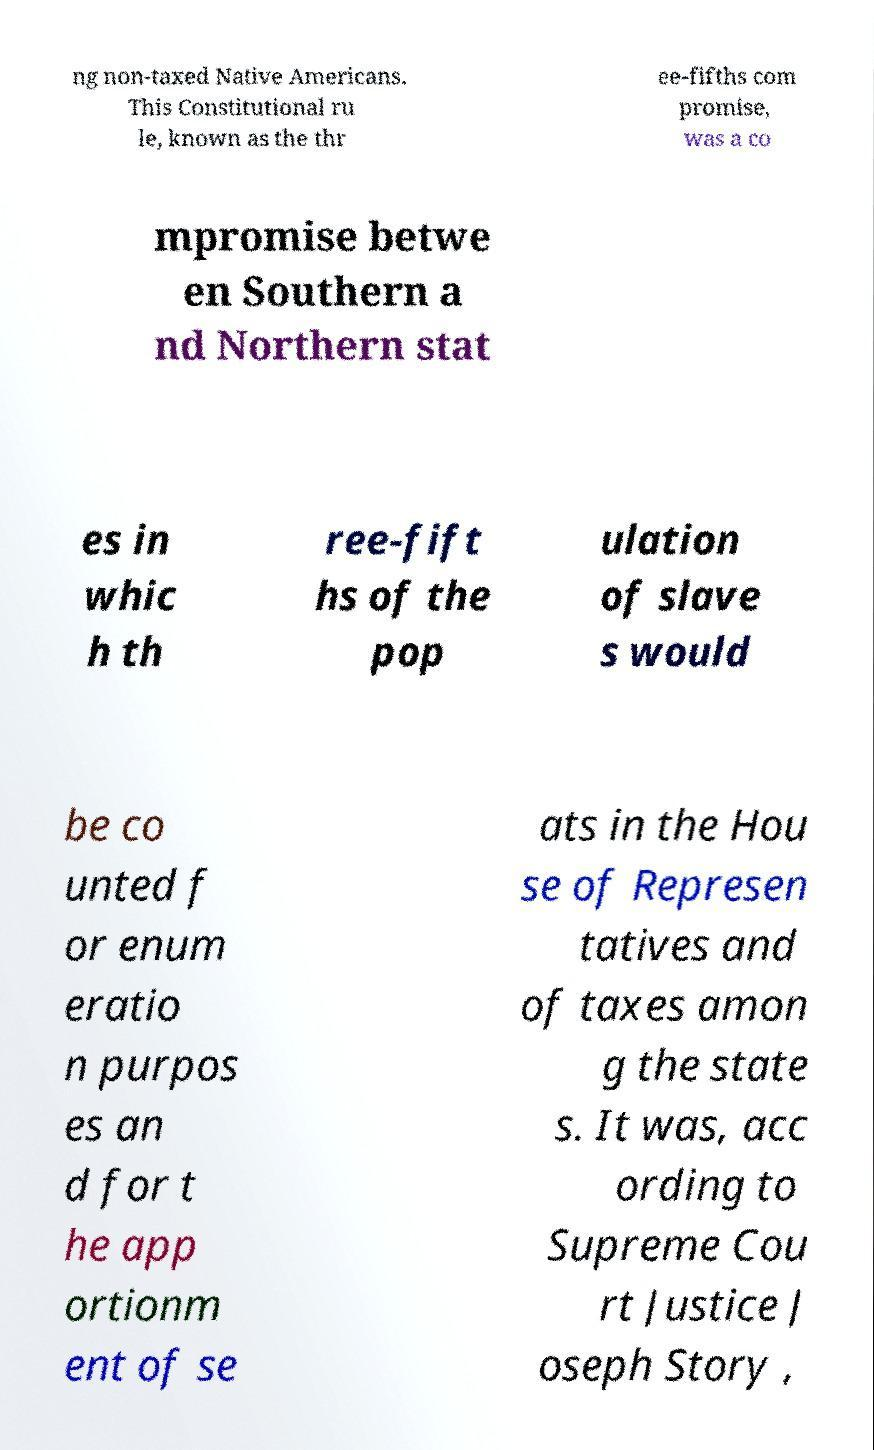What messages or text are displayed in this image? I need them in a readable, typed format. ng non-taxed Native Americans. This Constitutional ru le, known as the thr ee-fifths com promise, was a co mpromise betwe en Southern a nd Northern stat es in whic h th ree-fift hs of the pop ulation of slave s would be co unted f or enum eratio n purpos es an d for t he app ortionm ent of se ats in the Hou se of Represen tatives and of taxes amon g the state s. It was, acc ording to Supreme Cou rt Justice J oseph Story , 